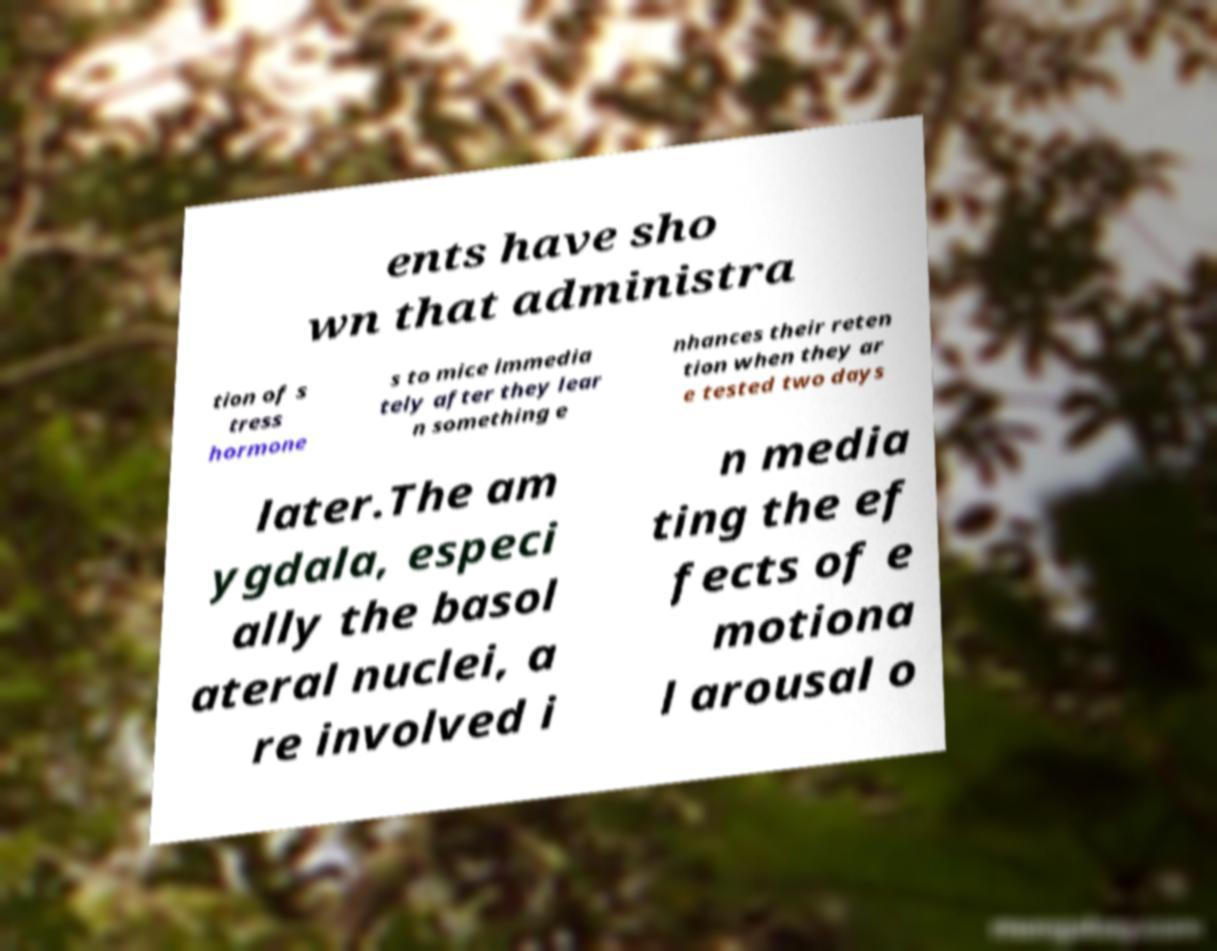Can you accurately transcribe the text from the provided image for me? ents have sho wn that administra tion of s tress hormone s to mice immedia tely after they lear n something e nhances their reten tion when they ar e tested two days later.The am ygdala, especi ally the basol ateral nuclei, a re involved i n media ting the ef fects of e motiona l arousal o 